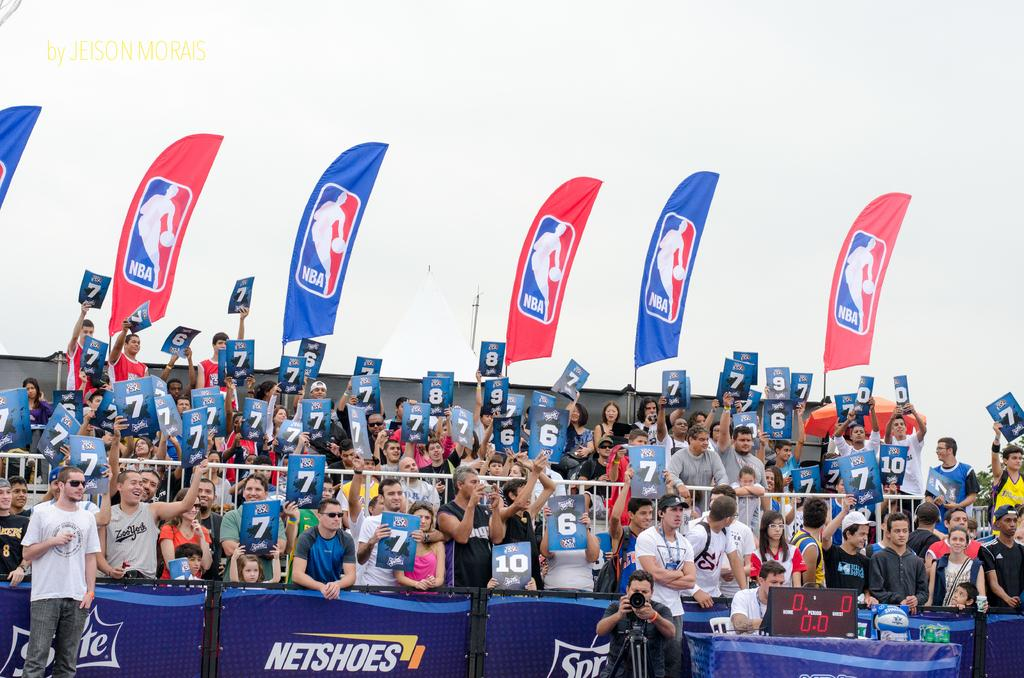What is the main focus of the image? The main focus of the image is the people in the center. What are the people holding in their hands? The people are holding number posters in their hands. Can you describe the bottom part of the image? There is a boundary at the bottom side of the image. What type of oil can be seen dripping from the spade in the image? There is no oil or spade present in the image. 